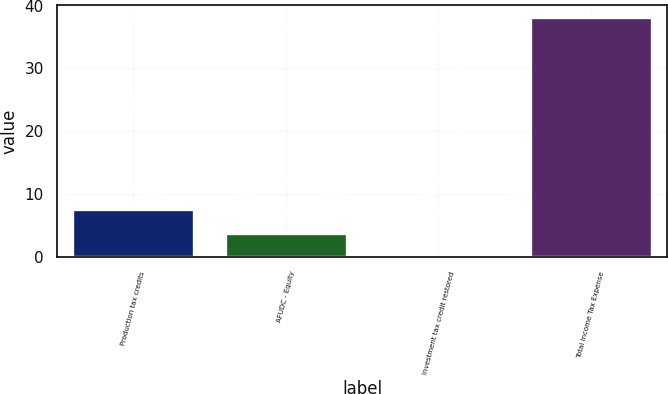Convert chart. <chart><loc_0><loc_0><loc_500><loc_500><bar_chart><fcel>Production tax credits<fcel>AFUDC - Equity<fcel>Investment tax credit restored<fcel>Total Income Tax Expense<nl><fcel>7.7<fcel>3.9<fcel>0.1<fcel>38.1<nl></chart> 